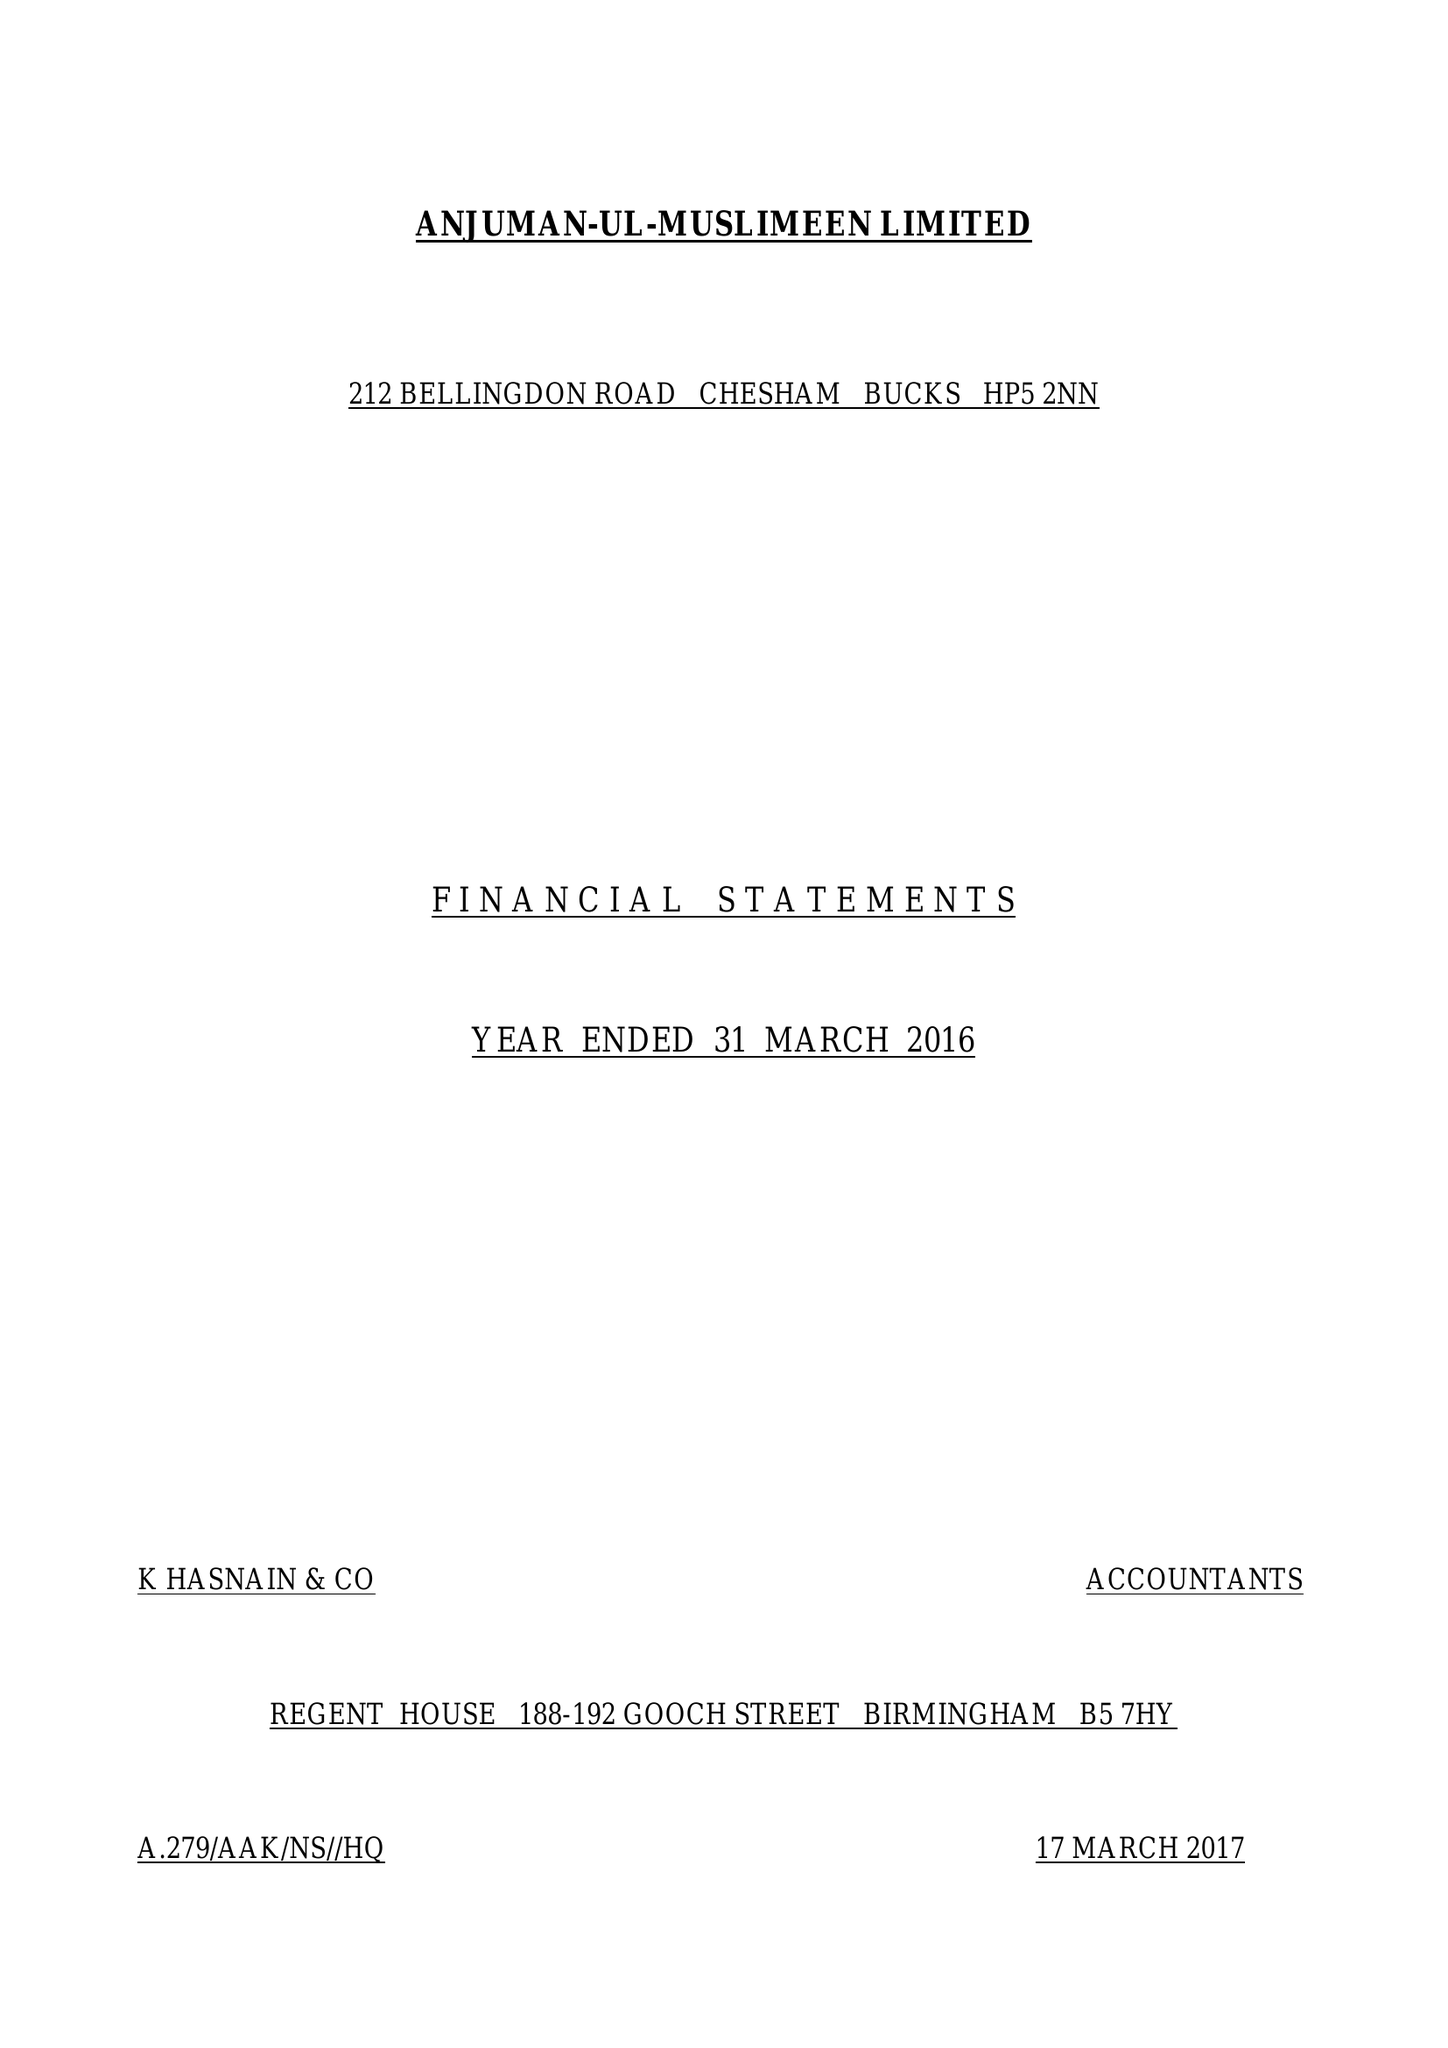What is the value for the report_date?
Answer the question using a single word or phrase. 2016-03-31 